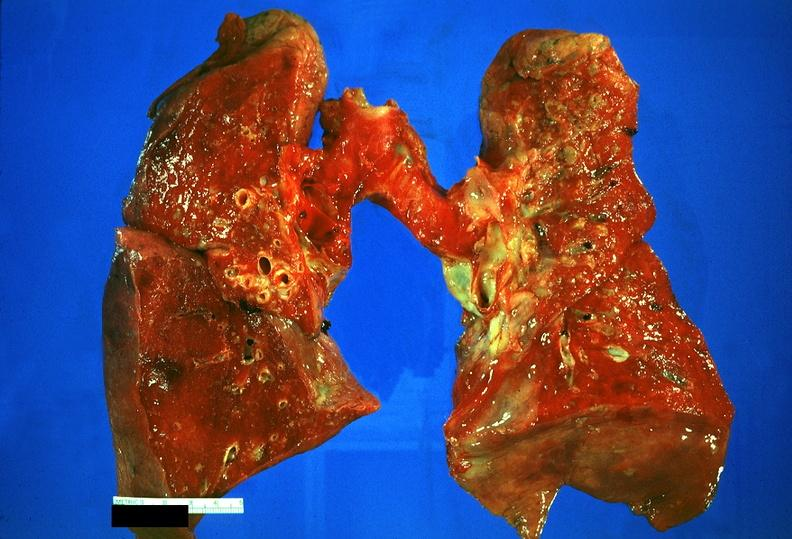what is present?
Answer the question using a single word or phrase. Respiratory 